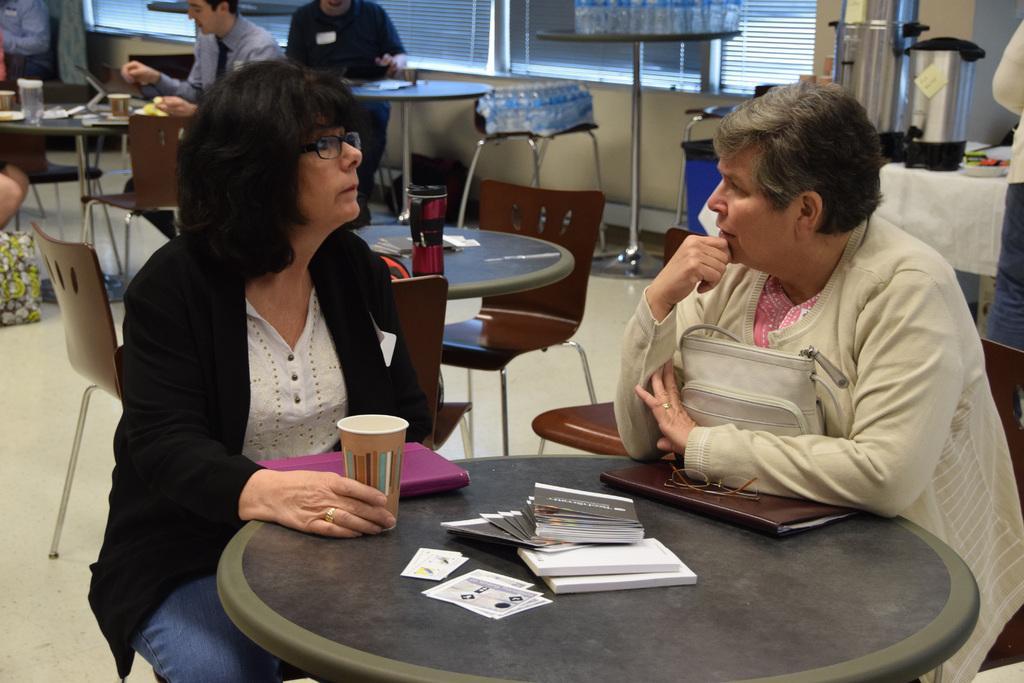Please provide a concise description of this image. This Picture describes about group of people, they are seated on the chair and one person standing, in the middle of the given image two women's are talking to each other in front of them we can find a bag, spectacles, books and some papers, cups on the table, in the background we can see couple of bottles on the table and a Window blind. 